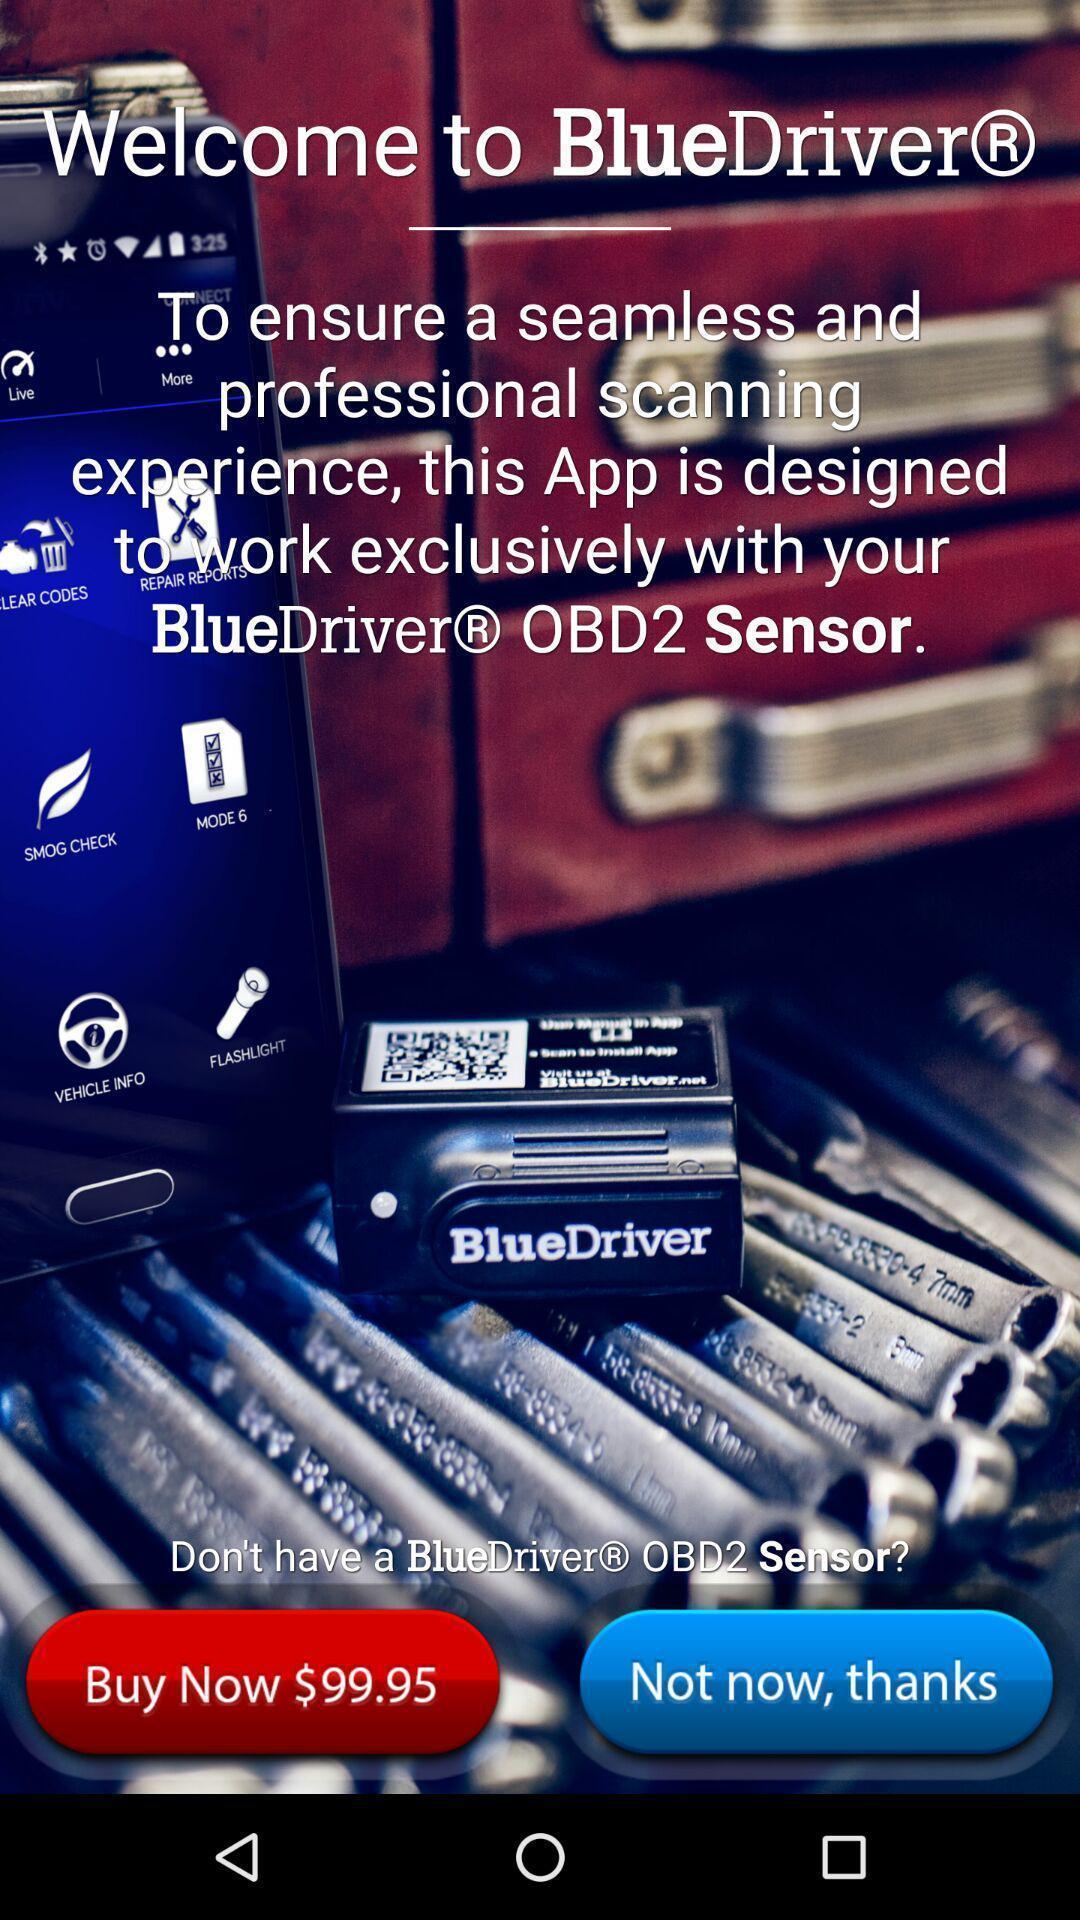Explain the elements present in this screenshot. Welcome page of social app. 